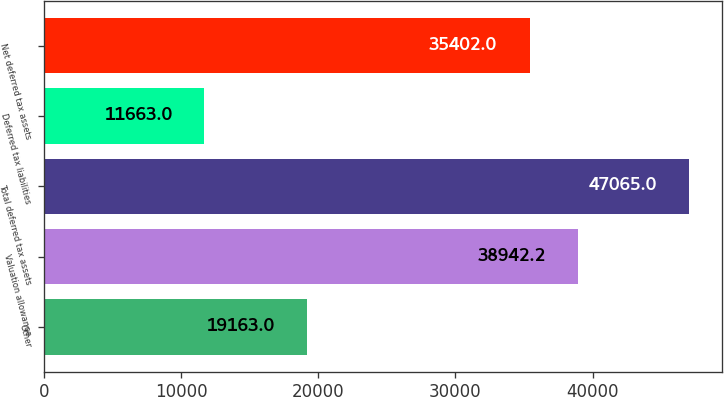Convert chart to OTSL. <chart><loc_0><loc_0><loc_500><loc_500><bar_chart><fcel>Other<fcel>Valuation allowance<fcel>Total deferred tax assets<fcel>Deferred tax liabilities<fcel>Net deferred tax assets<nl><fcel>19163<fcel>38942.2<fcel>47065<fcel>11663<fcel>35402<nl></chart> 